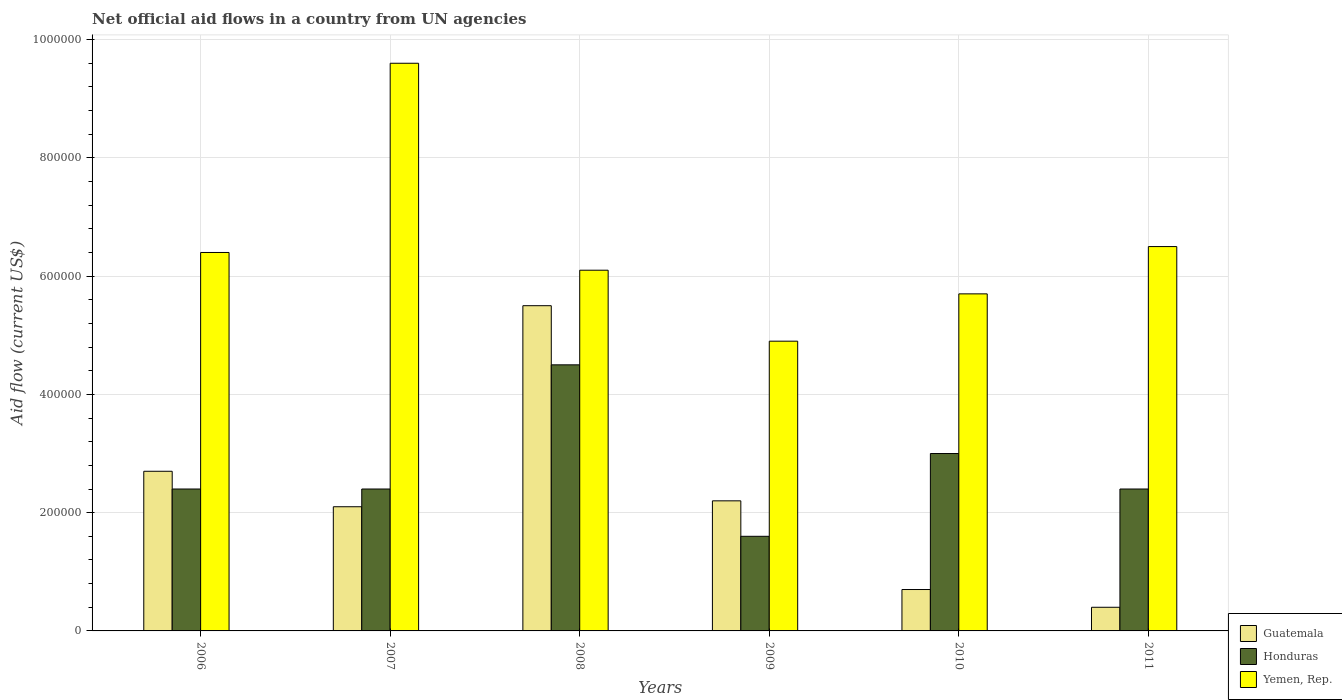How many different coloured bars are there?
Offer a very short reply. 3. How many groups of bars are there?
Provide a short and direct response. 6. Are the number of bars on each tick of the X-axis equal?
Give a very brief answer. Yes. What is the net official aid flow in Guatemala in 2010?
Make the answer very short. 7.00e+04. Across all years, what is the maximum net official aid flow in Yemen, Rep.?
Provide a succinct answer. 9.60e+05. Across all years, what is the minimum net official aid flow in Honduras?
Offer a terse response. 1.60e+05. In which year was the net official aid flow in Honduras maximum?
Provide a short and direct response. 2008. What is the total net official aid flow in Guatemala in the graph?
Offer a terse response. 1.36e+06. What is the difference between the net official aid flow in Yemen, Rep. in 2008 and that in 2011?
Make the answer very short. -4.00e+04. What is the difference between the net official aid flow in Yemen, Rep. in 2011 and the net official aid flow in Guatemala in 2009?
Make the answer very short. 4.30e+05. What is the average net official aid flow in Yemen, Rep. per year?
Provide a succinct answer. 6.53e+05. In the year 2010, what is the difference between the net official aid flow in Honduras and net official aid flow in Yemen, Rep.?
Give a very brief answer. -2.70e+05. What is the ratio of the net official aid flow in Yemen, Rep. in 2006 to that in 2010?
Provide a short and direct response. 1.12. Is the net official aid flow in Guatemala in 2008 less than that in 2009?
Your response must be concise. No. What is the difference between the highest and the lowest net official aid flow in Yemen, Rep.?
Offer a very short reply. 4.70e+05. What does the 3rd bar from the left in 2009 represents?
Your answer should be very brief. Yemen, Rep. What does the 1st bar from the right in 2009 represents?
Provide a short and direct response. Yemen, Rep. Is it the case that in every year, the sum of the net official aid flow in Guatemala and net official aid flow in Yemen, Rep. is greater than the net official aid flow in Honduras?
Make the answer very short. Yes. Are all the bars in the graph horizontal?
Give a very brief answer. No. Are the values on the major ticks of Y-axis written in scientific E-notation?
Provide a succinct answer. No. Where does the legend appear in the graph?
Keep it short and to the point. Bottom right. How many legend labels are there?
Provide a short and direct response. 3. What is the title of the graph?
Offer a very short reply. Net official aid flows in a country from UN agencies. What is the Aid flow (current US$) in Guatemala in 2006?
Your response must be concise. 2.70e+05. What is the Aid flow (current US$) in Yemen, Rep. in 2006?
Your answer should be compact. 6.40e+05. What is the Aid flow (current US$) of Honduras in 2007?
Your response must be concise. 2.40e+05. What is the Aid flow (current US$) in Yemen, Rep. in 2007?
Your answer should be very brief. 9.60e+05. What is the Aid flow (current US$) of Guatemala in 2008?
Provide a succinct answer. 5.50e+05. What is the Aid flow (current US$) in Honduras in 2008?
Ensure brevity in your answer.  4.50e+05. What is the Aid flow (current US$) of Yemen, Rep. in 2008?
Offer a terse response. 6.10e+05. What is the Aid flow (current US$) of Guatemala in 2010?
Offer a terse response. 7.00e+04. What is the Aid flow (current US$) of Honduras in 2010?
Your response must be concise. 3.00e+05. What is the Aid flow (current US$) in Yemen, Rep. in 2010?
Provide a succinct answer. 5.70e+05. What is the Aid flow (current US$) in Honduras in 2011?
Keep it short and to the point. 2.40e+05. What is the Aid flow (current US$) in Yemen, Rep. in 2011?
Make the answer very short. 6.50e+05. Across all years, what is the maximum Aid flow (current US$) of Guatemala?
Give a very brief answer. 5.50e+05. Across all years, what is the maximum Aid flow (current US$) of Yemen, Rep.?
Your answer should be compact. 9.60e+05. Across all years, what is the minimum Aid flow (current US$) in Honduras?
Offer a very short reply. 1.60e+05. Across all years, what is the minimum Aid flow (current US$) of Yemen, Rep.?
Provide a short and direct response. 4.90e+05. What is the total Aid flow (current US$) in Guatemala in the graph?
Keep it short and to the point. 1.36e+06. What is the total Aid flow (current US$) of Honduras in the graph?
Offer a terse response. 1.63e+06. What is the total Aid flow (current US$) in Yemen, Rep. in the graph?
Your answer should be compact. 3.92e+06. What is the difference between the Aid flow (current US$) in Honduras in 2006 and that in 2007?
Offer a very short reply. 0. What is the difference between the Aid flow (current US$) in Yemen, Rep. in 2006 and that in 2007?
Keep it short and to the point. -3.20e+05. What is the difference between the Aid flow (current US$) in Guatemala in 2006 and that in 2008?
Your response must be concise. -2.80e+05. What is the difference between the Aid flow (current US$) in Honduras in 2006 and that in 2008?
Your answer should be compact. -2.10e+05. What is the difference between the Aid flow (current US$) in Guatemala in 2006 and that in 2009?
Make the answer very short. 5.00e+04. What is the difference between the Aid flow (current US$) of Honduras in 2006 and that in 2009?
Offer a very short reply. 8.00e+04. What is the difference between the Aid flow (current US$) of Guatemala in 2006 and that in 2011?
Provide a succinct answer. 2.30e+05. What is the difference between the Aid flow (current US$) in Honduras in 2006 and that in 2011?
Offer a very short reply. 0. What is the difference between the Aid flow (current US$) in Honduras in 2007 and that in 2010?
Your answer should be compact. -6.00e+04. What is the difference between the Aid flow (current US$) in Yemen, Rep. in 2007 and that in 2010?
Your answer should be very brief. 3.90e+05. What is the difference between the Aid flow (current US$) in Honduras in 2007 and that in 2011?
Your answer should be very brief. 0. What is the difference between the Aid flow (current US$) in Yemen, Rep. in 2007 and that in 2011?
Your answer should be very brief. 3.10e+05. What is the difference between the Aid flow (current US$) in Guatemala in 2008 and that in 2009?
Offer a terse response. 3.30e+05. What is the difference between the Aid flow (current US$) in Yemen, Rep. in 2008 and that in 2009?
Offer a very short reply. 1.20e+05. What is the difference between the Aid flow (current US$) of Guatemala in 2008 and that in 2010?
Provide a succinct answer. 4.80e+05. What is the difference between the Aid flow (current US$) in Guatemala in 2008 and that in 2011?
Keep it short and to the point. 5.10e+05. What is the difference between the Aid flow (current US$) of Yemen, Rep. in 2008 and that in 2011?
Offer a terse response. -4.00e+04. What is the difference between the Aid flow (current US$) of Guatemala in 2009 and that in 2010?
Offer a terse response. 1.50e+05. What is the difference between the Aid flow (current US$) in Honduras in 2009 and that in 2011?
Ensure brevity in your answer.  -8.00e+04. What is the difference between the Aid flow (current US$) of Yemen, Rep. in 2009 and that in 2011?
Your response must be concise. -1.60e+05. What is the difference between the Aid flow (current US$) in Guatemala in 2010 and that in 2011?
Provide a succinct answer. 3.00e+04. What is the difference between the Aid flow (current US$) of Yemen, Rep. in 2010 and that in 2011?
Give a very brief answer. -8.00e+04. What is the difference between the Aid flow (current US$) of Guatemala in 2006 and the Aid flow (current US$) of Yemen, Rep. in 2007?
Ensure brevity in your answer.  -6.90e+05. What is the difference between the Aid flow (current US$) of Honduras in 2006 and the Aid flow (current US$) of Yemen, Rep. in 2007?
Make the answer very short. -7.20e+05. What is the difference between the Aid flow (current US$) in Guatemala in 2006 and the Aid flow (current US$) in Yemen, Rep. in 2008?
Keep it short and to the point. -3.40e+05. What is the difference between the Aid flow (current US$) in Honduras in 2006 and the Aid flow (current US$) in Yemen, Rep. in 2008?
Give a very brief answer. -3.70e+05. What is the difference between the Aid flow (current US$) of Guatemala in 2006 and the Aid flow (current US$) of Yemen, Rep. in 2009?
Make the answer very short. -2.20e+05. What is the difference between the Aid flow (current US$) in Honduras in 2006 and the Aid flow (current US$) in Yemen, Rep. in 2010?
Your answer should be compact. -3.30e+05. What is the difference between the Aid flow (current US$) of Guatemala in 2006 and the Aid flow (current US$) of Honduras in 2011?
Provide a short and direct response. 3.00e+04. What is the difference between the Aid flow (current US$) in Guatemala in 2006 and the Aid flow (current US$) in Yemen, Rep. in 2011?
Your answer should be very brief. -3.80e+05. What is the difference between the Aid flow (current US$) in Honduras in 2006 and the Aid flow (current US$) in Yemen, Rep. in 2011?
Your response must be concise. -4.10e+05. What is the difference between the Aid flow (current US$) in Guatemala in 2007 and the Aid flow (current US$) in Honduras in 2008?
Provide a succinct answer. -2.40e+05. What is the difference between the Aid flow (current US$) in Guatemala in 2007 and the Aid flow (current US$) in Yemen, Rep. in 2008?
Provide a succinct answer. -4.00e+05. What is the difference between the Aid flow (current US$) of Honduras in 2007 and the Aid flow (current US$) of Yemen, Rep. in 2008?
Provide a succinct answer. -3.70e+05. What is the difference between the Aid flow (current US$) of Guatemala in 2007 and the Aid flow (current US$) of Yemen, Rep. in 2009?
Your response must be concise. -2.80e+05. What is the difference between the Aid flow (current US$) of Honduras in 2007 and the Aid flow (current US$) of Yemen, Rep. in 2009?
Give a very brief answer. -2.50e+05. What is the difference between the Aid flow (current US$) in Guatemala in 2007 and the Aid flow (current US$) in Yemen, Rep. in 2010?
Give a very brief answer. -3.60e+05. What is the difference between the Aid flow (current US$) of Honduras in 2007 and the Aid flow (current US$) of Yemen, Rep. in 2010?
Provide a short and direct response. -3.30e+05. What is the difference between the Aid flow (current US$) in Guatemala in 2007 and the Aid flow (current US$) in Yemen, Rep. in 2011?
Your answer should be very brief. -4.40e+05. What is the difference between the Aid flow (current US$) of Honduras in 2007 and the Aid flow (current US$) of Yemen, Rep. in 2011?
Provide a short and direct response. -4.10e+05. What is the difference between the Aid flow (current US$) of Honduras in 2008 and the Aid flow (current US$) of Yemen, Rep. in 2009?
Make the answer very short. -4.00e+04. What is the difference between the Aid flow (current US$) in Guatemala in 2008 and the Aid flow (current US$) in Honduras in 2010?
Keep it short and to the point. 2.50e+05. What is the difference between the Aid flow (current US$) of Guatemala in 2008 and the Aid flow (current US$) of Yemen, Rep. in 2010?
Your answer should be very brief. -2.00e+04. What is the difference between the Aid flow (current US$) in Honduras in 2008 and the Aid flow (current US$) in Yemen, Rep. in 2010?
Keep it short and to the point. -1.20e+05. What is the difference between the Aid flow (current US$) of Honduras in 2008 and the Aid flow (current US$) of Yemen, Rep. in 2011?
Offer a terse response. -2.00e+05. What is the difference between the Aid flow (current US$) in Guatemala in 2009 and the Aid flow (current US$) in Honduras in 2010?
Offer a very short reply. -8.00e+04. What is the difference between the Aid flow (current US$) of Guatemala in 2009 and the Aid flow (current US$) of Yemen, Rep. in 2010?
Offer a terse response. -3.50e+05. What is the difference between the Aid flow (current US$) in Honduras in 2009 and the Aid flow (current US$) in Yemen, Rep. in 2010?
Your answer should be compact. -4.10e+05. What is the difference between the Aid flow (current US$) in Guatemala in 2009 and the Aid flow (current US$) in Honduras in 2011?
Ensure brevity in your answer.  -2.00e+04. What is the difference between the Aid flow (current US$) in Guatemala in 2009 and the Aid flow (current US$) in Yemen, Rep. in 2011?
Provide a succinct answer. -4.30e+05. What is the difference between the Aid flow (current US$) in Honduras in 2009 and the Aid flow (current US$) in Yemen, Rep. in 2011?
Provide a short and direct response. -4.90e+05. What is the difference between the Aid flow (current US$) of Guatemala in 2010 and the Aid flow (current US$) of Yemen, Rep. in 2011?
Offer a terse response. -5.80e+05. What is the difference between the Aid flow (current US$) in Honduras in 2010 and the Aid flow (current US$) in Yemen, Rep. in 2011?
Make the answer very short. -3.50e+05. What is the average Aid flow (current US$) of Guatemala per year?
Ensure brevity in your answer.  2.27e+05. What is the average Aid flow (current US$) of Honduras per year?
Your answer should be very brief. 2.72e+05. What is the average Aid flow (current US$) of Yemen, Rep. per year?
Your answer should be very brief. 6.53e+05. In the year 2006, what is the difference between the Aid flow (current US$) of Guatemala and Aid flow (current US$) of Honduras?
Your answer should be compact. 3.00e+04. In the year 2006, what is the difference between the Aid flow (current US$) in Guatemala and Aid flow (current US$) in Yemen, Rep.?
Your answer should be very brief. -3.70e+05. In the year 2006, what is the difference between the Aid flow (current US$) of Honduras and Aid flow (current US$) of Yemen, Rep.?
Keep it short and to the point. -4.00e+05. In the year 2007, what is the difference between the Aid flow (current US$) of Guatemala and Aid flow (current US$) of Yemen, Rep.?
Offer a terse response. -7.50e+05. In the year 2007, what is the difference between the Aid flow (current US$) of Honduras and Aid flow (current US$) of Yemen, Rep.?
Offer a very short reply. -7.20e+05. In the year 2008, what is the difference between the Aid flow (current US$) in Honduras and Aid flow (current US$) in Yemen, Rep.?
Make the answer very short. -1.60e+05. In the year 2009, what is the difference between the Aid flow (current US$) of Guatemala and Aid flow (current US$) of Honduras?
Your answer should be very brief. 6.00e+04. In the year 2009, what is the difference between the Aid flow (current US$) in Guatemala and Aid flow (current US$) in Yemen, Rep.?
Give a very brief answer. -2.70e+05. In the year 2009, what is the difference between the Aid flow (current US$) of Honduras and Aid flow (current US$) of Yemen, Rep.?
Give a very brief answer. -3.30e+05. In the year 2010, what is the difference between the Aid flow (current US$) of Guatemala and Aid flow (current US$) of Yemen, Rep.?
Your answer should be very brief. -5.00e+05. In the year 2011, what is the difference between the Aid flow (current US$) of Guatemala and Aid flow (current US$) of Honduras?
Provide a short and direct response. -2.00e+05. In the year 2011, what is the difference between the Aid flow (current US$) of Guatemala and Aid flow (current US$) of Yemen, Rep.?
Your answer should be compact. -6.10e+05. In the year 2011, what is the difference between the Aid flow (current US$) in Honduras and Aid flow (current US$) in Yemen, Rep.?
Offer a terse response. -4.10e+05. What is the ratio of the Aid flow (current US$) in Guatemala in 2006 to that in 2007?
Make the answer very short. 1.29. What is the ratio of the Aid flow (current US$) in Honduras in 2006 to that in 2007?
Offer a very short reply. 1. What is the ratio of the Aid flow (current US$) of Yemen, Rep. in 2006 to that in 2007?
Ensure brevity in your answer.  0.67. What is the ratio of the Aid flow (current US$) of Guatemala in 2006 to that in 2008?
Offer a terse response. 0.49. What is the ratio of the Aid flow (current US$) of Honduras in 2006 to that in 2008?
Keep it short and to the point. 0.53. What is the ratio of the Aid flow (current US$) in Yemen, Rep. in 2006 to that in 2008?
Your answer should be compact. 1.05. What is the ratio of the Aid flow (current US$) in Guatemala in 2006 to that in 2009?
Make the answer very short. 1.23. What is the ratio of the Aid flow (current US$) in Yemen, Rep. in 2006 to that in 2009?
Provide a short and direct response. 1.31. What is the ratio of the Aid flow (current US$) of Guatemala in 2006 to that in 2010?
Provide a short and direct response. 3.86. What is the ratio of the Aid flow (current US$) in Honduras in 2006 to that in 2010?
Make the answer very short. 0.8. What is the ratio of the Aid flow (current US$) in Yemen, Rep. in 2006 to that in 2010?
Provide a succinct answer. 1.12. What is the ratio of the Aid flow (current US$) in Guatemala in 2006 to that in 2011?
Your response must be concise. 6.75. What is the ratio of the Aid flow (current US$) of Honduras in 2006 to that in 2011?
Offer a terse response. 1. What is the ratio of the Aid flow (current US$) in Yemen, Rep. in 2006 to that in 2011?
Your answer should be very brief. 0.98. What is the ratio of the Aid flow (current US$) in Guatemala in 2007 to that in 2008?
Offer a terse response. 0.38. What is the ratio of the Aid flow (current US$) of Honduras in 2007 to that in 2008?
Give a very brief answer. 0.53. What is the ratio of the Aid flow (current US$) in Yemen, Rep. in 2007 to that in 2008?
Offer a terse response. 1.57. What is the ratio of the Aid flow (current US$) in Guatemala in 2007 to that in 2009?
Make the answer very short. 0.95. What is the ratio of the Aid flow (current US$) in Honduras in 2007 to that in 2009?
Provide a short and direct response. 1.5. What is the ratio of the Aid flow (current US$) in Yemen, Rep. in 2007 to that in 2009?
Provide a succinct answer. 1.96. What is the ratio of the Aid flow (current US$) in Guatemala in 2007 to that in 2010?
Offer a terse response. 3. What is the ratio of the Aid flow (current US$) of Honduras in 2007 to that in 2010?
Your answer should be compact. 0.8. What is the ratio of the Aid flow (current US$) of Yemen, Rep. in 2007 to that in 2010?
Ensure brevity in your answer.  1.68. What is the ratio of the Aid flow (current US$) of Guatemala in 2007 to that in 2011?
Provide a short and direct response. 5.25. What is the ratio of the Aid flow (current US$) in Honduras in 2007 to that in 2011?
Your response must be concise. 1. What is the ratio of the Aid flow (current US$) in Yemen, Rep. in 2007 to that in 2011?
Keep it short and to the point. 1.48. What is the ratio of the Aid flow (current US$) of Guatemala in 2008 to that in 2009?
Ensure brevity in your answer.  2.5. What is the ratio of the Aid flow (current US$) of Honduras in 2008 to that in 2009?
Provide a short and direct response. 2.81. What is the ratio of the Aid flow (current US$) of Yemen, Rep. in 2008 to that in 2009?
Keep it short and to the point. 1.24. What is the ratio of the Aid flow (current US$) of Guatemala in 2008 to that in 2010?
Your response must be concise. 7.86. What is the ratio of the Aid flow (current US$) of Honduras in 2008 to that in 2010?
Provide a succinct answer. 1.5. What is the ratio of the Aid flow (current US$) of Yemen, Rep. in 2008 to that in 2010?
Offer a terse response. 1.07. What is the ratio of the Aid flow (current US$) in Guatemala in 2008 to that in 2011?
Provide a succinct answer. 13.75. What is the ratio of the Aid flow (current US$) in Honduras in 2008 to that in 2011?
Make the answer very short. 1.88. What is the ratio of the Aid flow (current US$) in Yemen, Rep. in 2008 to that in 2011?
Keep it short and to the point. 0.94. What is the ratio of the Aid flow (current US$) of Guatemala in 2009 to that in 2010?
Your answer should be compact. 3.14. What is the ratio of the Aid flow (current US$) of Honduras in 2009 to that in 2010?
Keep it short and to the point. 0.53. What is the ratio of the Aid flow (current US$) of Yemen, Rep. in 2009 to that in 2010?
Offer a terse response. 0.86. What is the ratio of the Aid flow (current US$) in Guatemala in 2009 to that in 2011?
Ensure brevity in your answer.  5.5. What is the ratio of the Aid flow (current US$) in Honduras in 2009 to that in 2011?
Your answer should be compact. 0.67. What is the ratio of the Aid flow (current US$) of Yemen, Rep. in 2009 to that in 2011?
Give a very brief answer. 0.75. What is the ratio of the Aid flow (current US$) of Guatemala in 2010 to that in 2011?
Give a very brief answer. 1.75. What is the ratio of the Aid flow (current US$) in Honduras in 2010 to that in 2011?
Give a very brief answer. 1.25. What is the ratio of the Aid flow (current US$) in Yemen, Rep. in 2010 to that in 2011?
Offer a very short reply. 0.88. What is the difference between the highest and the second highest Aid flow (current US$) of Guatemala?
Ensure brevity in your answer.  2.80e+05. What is the difference between the highest and the second highest Aid flow (current US$) in Honduras?
Offer a very short reply. 1.50e+05. What is the difference between the highest and the second highest Aid flow (current US$) in Yemen, Rep.?
Provide a succinct answer. 3.10e+05. What is the difference between the highest and the lowest Aid flow (current US$) in Guatemala?
Provide a short and direct response. 5.10e+05. What is the difference between the highest and the lowest Aid flow (current US$) in Yemen, Rep.?
Your answer should be compact. 4.70e+05. 